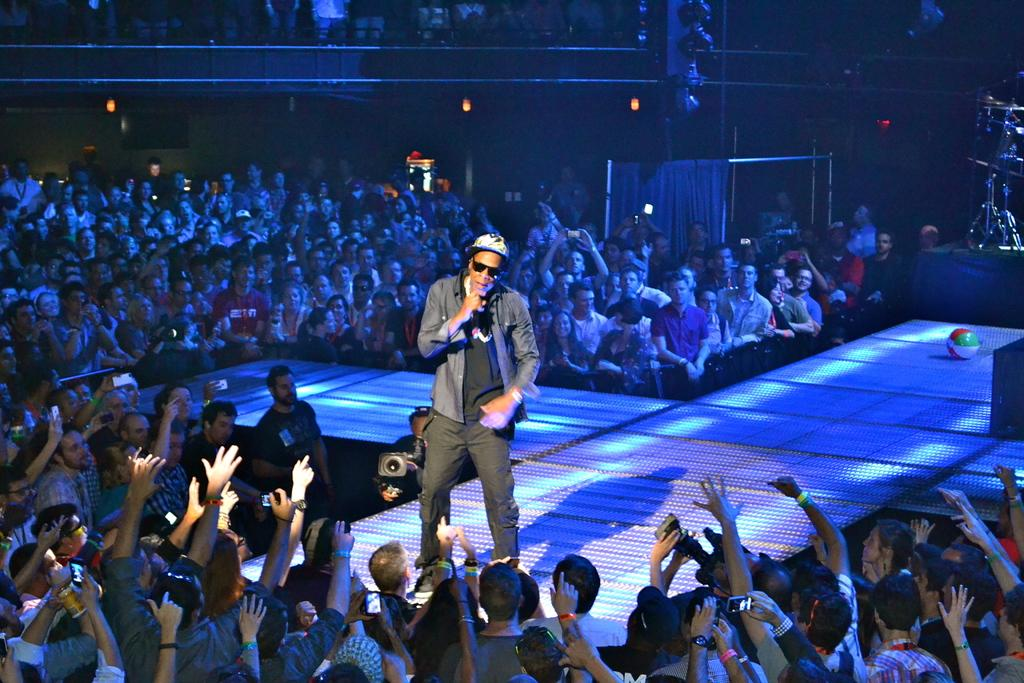What is the main subject of the image? There is a man standing in the middle of the image. What is the man doing in the image? The man is singing a song. How are the people around the man reacting? Many people are raising their hands towards the man. What language is the ladybug speaking in the image? There is no ladybug present in the image, so it is not possible to determine the language it might be speaking. 